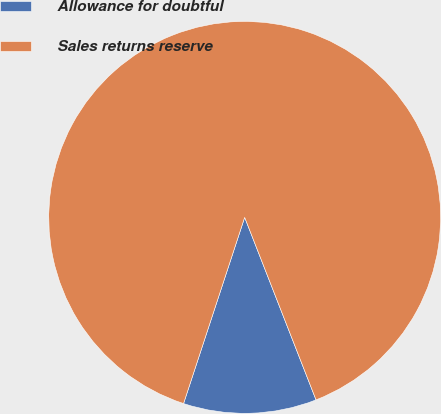Convert chart to OTSL. <chart><loc_0><loc_0><loc_500><loc_500><pie_chart><fcel>Allowance for doubtful<fcel>Sales returns reserve<nl><fcel>10.98%<fcel>89.02%<nl></chart> 